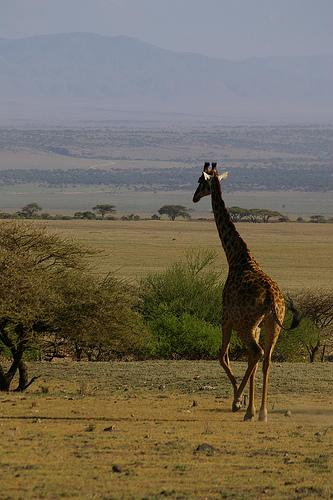What are some prominent features of the background in this image? In the background, there are tall mountains, a hazy sky, and a line of trees below the giraffe, as well as trees with green leaves and haze in front of the mountain range. What animal is present in the image and what action is it performing? A giraffe is walking in the meadow, with its tail on the right side and knees bent in different directions. Perform a complex reasoning task: Why might the giraffe be running through the meadow? The giraffe could be running through the meadow due to the presence of a predator, following a companion, or simply engaging in playful behavior within its natural habitat. Identify the setting of the image in terms of landscape and vegetation. The image shows a savanna with short grass, bushes in the meadow, and a variety of green trees scattered across the field, with some having flat tops. What can you say about the giraffe's physical features and appearance? The giraffe is brown, has a long neck, two horns, and a furry black tail. Its mane is also brown and it has large spots on its body. Please describe the position of the giraffe with respect to the camera. The giraffe is facing away from the camera while walking in the meadow, with its head also facing away. Identify the visible parts of the giraffe's legs. The visible parts of the giraffe's legs include its knees, which are bent in different directions while the animal is walking. Describe the overall sentiment or mood depicted in this image. The image conveys a serene and peaceful mood, with a giraffe casually walking through a vast savanna with majestic mountains in the distance. What unusual feature can you observe about the giraffe's tail? The giraffe's tail appears to be swinging in a loop, with the tuft of the tail being black. Analyze the ground on which the giraffe is walking. The giraffe is walking on a yellowish ground that leads to greener and rougher ground, with some areas having no grass and being littered with natural debris. Describe the overall setting of the image. The image displays a giraffe walking in a meadow with trees, bushes, and mountains in the background, under a hazy sky. What can you see in the background of the image? There are trees with flat tops and tall mountains in the background of the image. Determine if the giraffe is facing towards or away from the camera. The giraffe is facing away from the camera. Is the giraffe's tail still, or is it in motion? The giraffe's tail is in motion, possibly fluttering. The giraffe is standing still. No, it's not mentioned in the image. Identify and describe the main object in the image. The main object is a large spotted brown giraffe walking in a meadow. Does the giraffe have a short neck? There are captions saying "the giraffe has a long neck", which contradicts this instruction. Can you see a body of water in the background? There is no mention of any body of water, so this instruction is misleading. Based on the animal's posture, is the giraffe more likely walking or running? The giraffe is more likely walking. Describe the grass in the image. The grass is short. Which of the following best describes the position of the giraffe's tail? a) Left side of the giraffe. b) Right side of the giraffe. c) Not visible. b) Right side of the giraffe. What is the color of the sky in the image? The sky is hazy. Are the giraffe's knees bent in the same or in different directions? The giraffe's knees are bent in different directions. What is the color of the tuft of the giraffe's tail? The tuft of the tail is black. Write a sentence describing the appearance of the giraffe's mane. The mane of the giraffe is brown. Explain the appearance of the tree leaves in the image. The tree leaves are green. Is the giraffe walking towards the camera? The correct information is "giraffe facing away from camera", so saying it's walking towards the camera is misleading. Identify and describe the trees in the image. The trees have green leaves, form patterns on the plain, and are shorter in the foreground with flat tops. The sky is clear and blue. The correct information is "the sky is hazy", so stating it's clear and blue is misleading. From the image, determine the color of the giraffe. The giraffe is brown. Which of these statements accurately describes the giraffe in the image? a) The giraffe is running. b) The giraffe is walking. c) The giraffe is sitting. d) The giraffe is standing still.  b) The giraffe is walking. The mane of the giraffe is blue. The correct information is "mane of giraffe is brown", so stating it's blue is misleading. What type of terrain and vegetation can be seen in the image alongside the giraffe? There is short grass, bushes, and trees in the meadow, with a mountainous background. Describe the ground in the image. The ground has patches of short grass and is littered with natural debris. Is the ground in the image completely covered in grass or not? The ground is not completely covered in grass. 